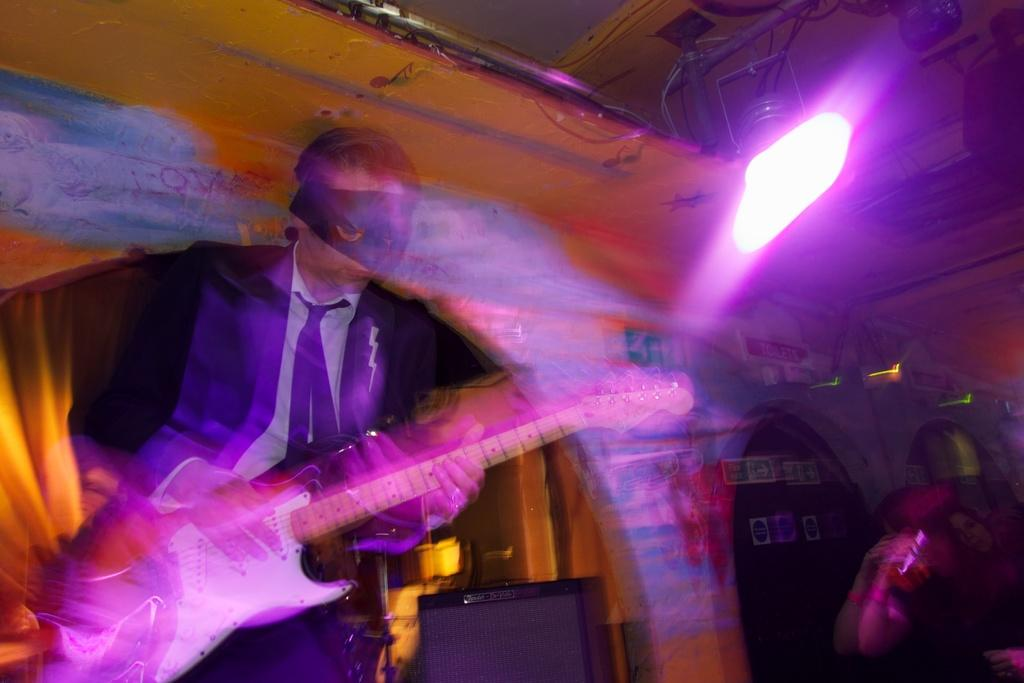What is the man in the image doing? The man is playing the guitar in the image. What type of clothing is the man wearing? The man is wearing a tie, a shirt, and a coat. Can you describe the lighting in the image? There is a light on the right side of the image. How does the man push the cub out of the quicksand in the image? There is no cub or quicksand present in the image; the man is playing the guitar and wearing a tie, shirt, and coat. 